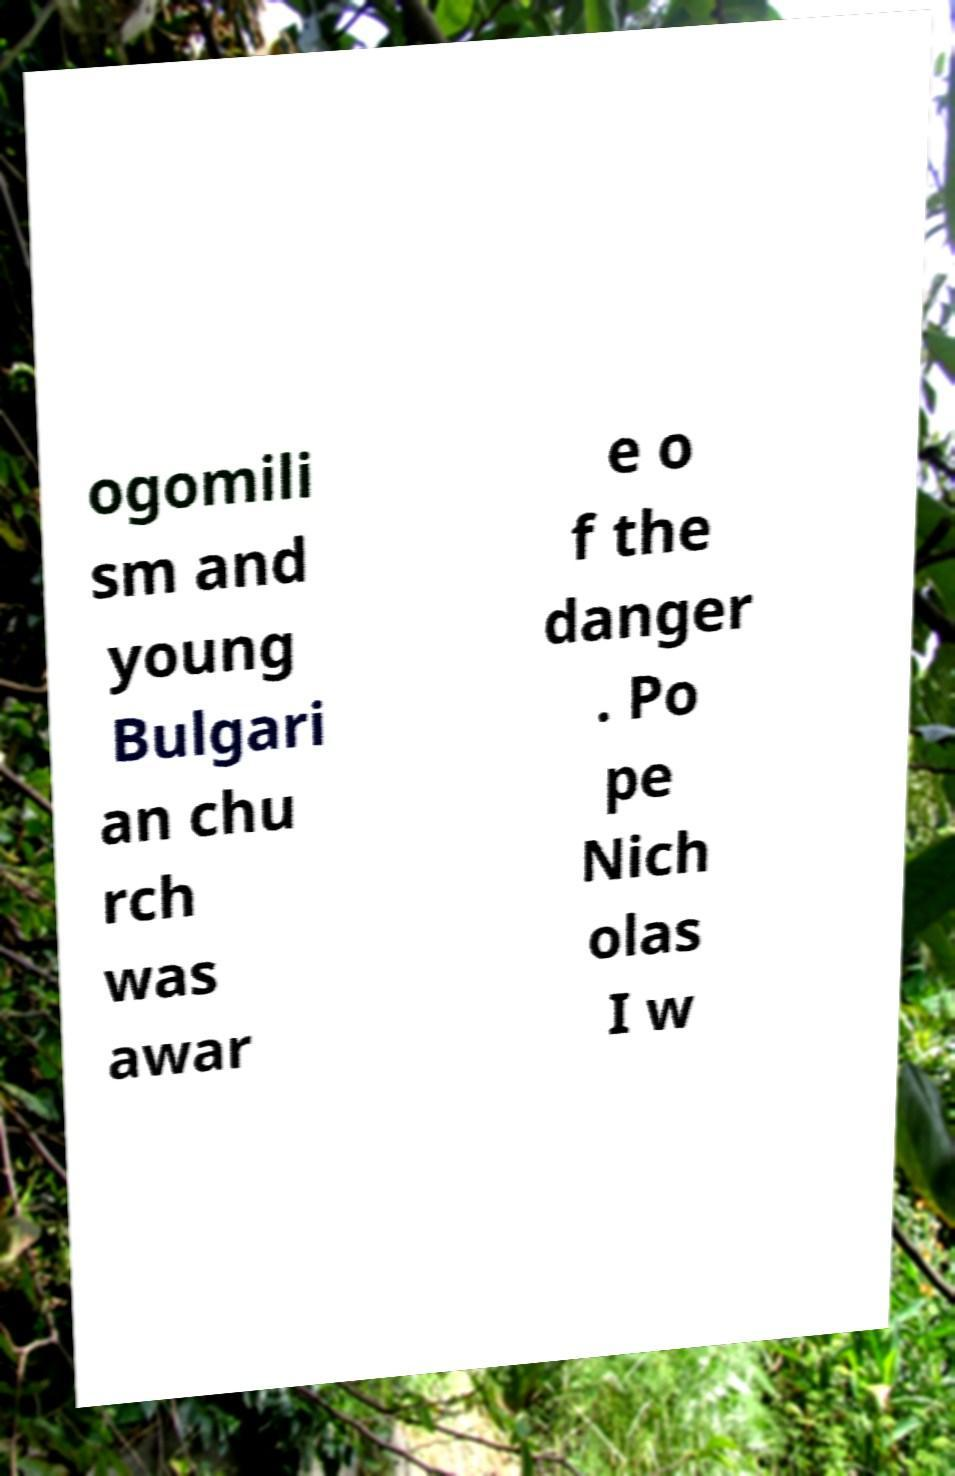Can you read and provide the text displayed in the image?This photo seems to have some interesting text. Can you extract and type it out for me? ogomili sm and young Bulgari an chu rch was awar e o f the danger . Po pe Nich olas I w 